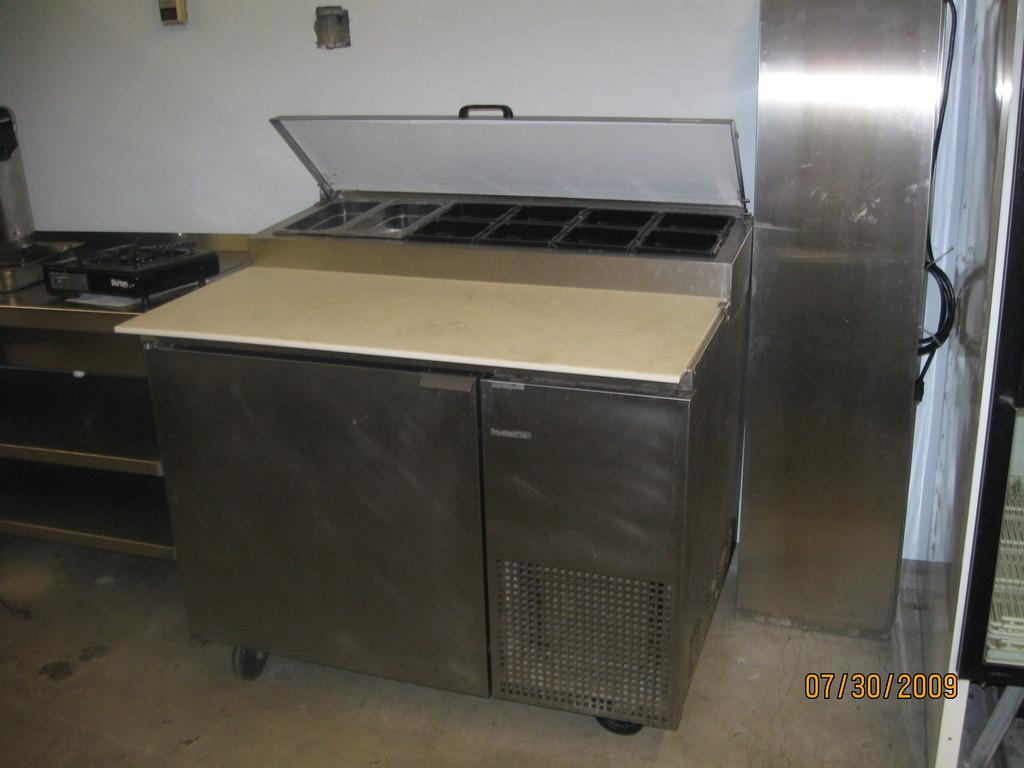<image>
Describe the image concisely. A clean stainless steel Ban Marie sits in an empty kitchen. 